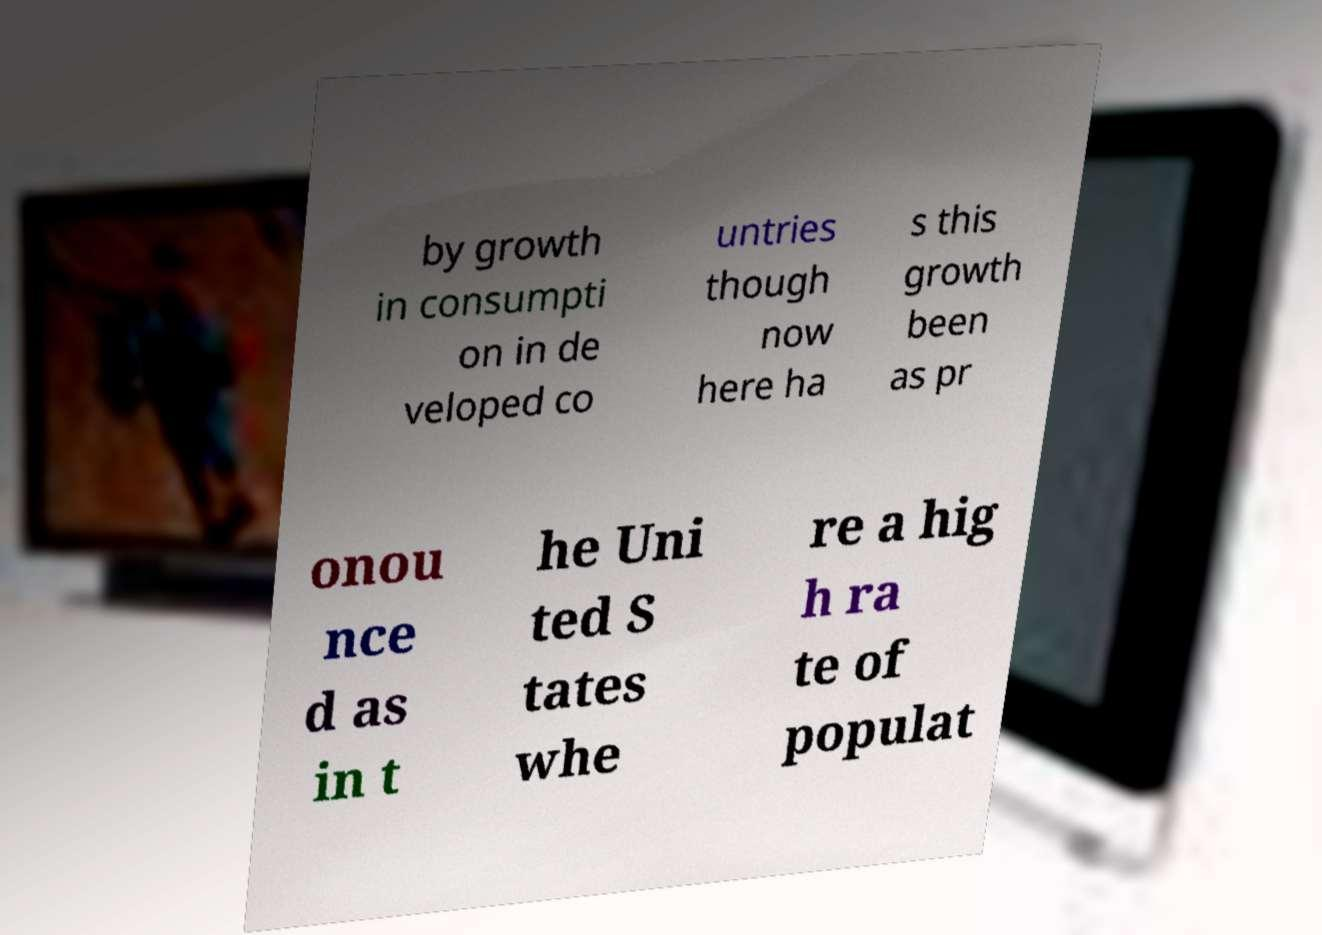Please identify and transcribe the text found in this image. by growth in consumpti on in de veloped co untries though now here ha s this growth been as pr onou nce d as in t he Uni ted S tates whe re a hig h ra te of populat 